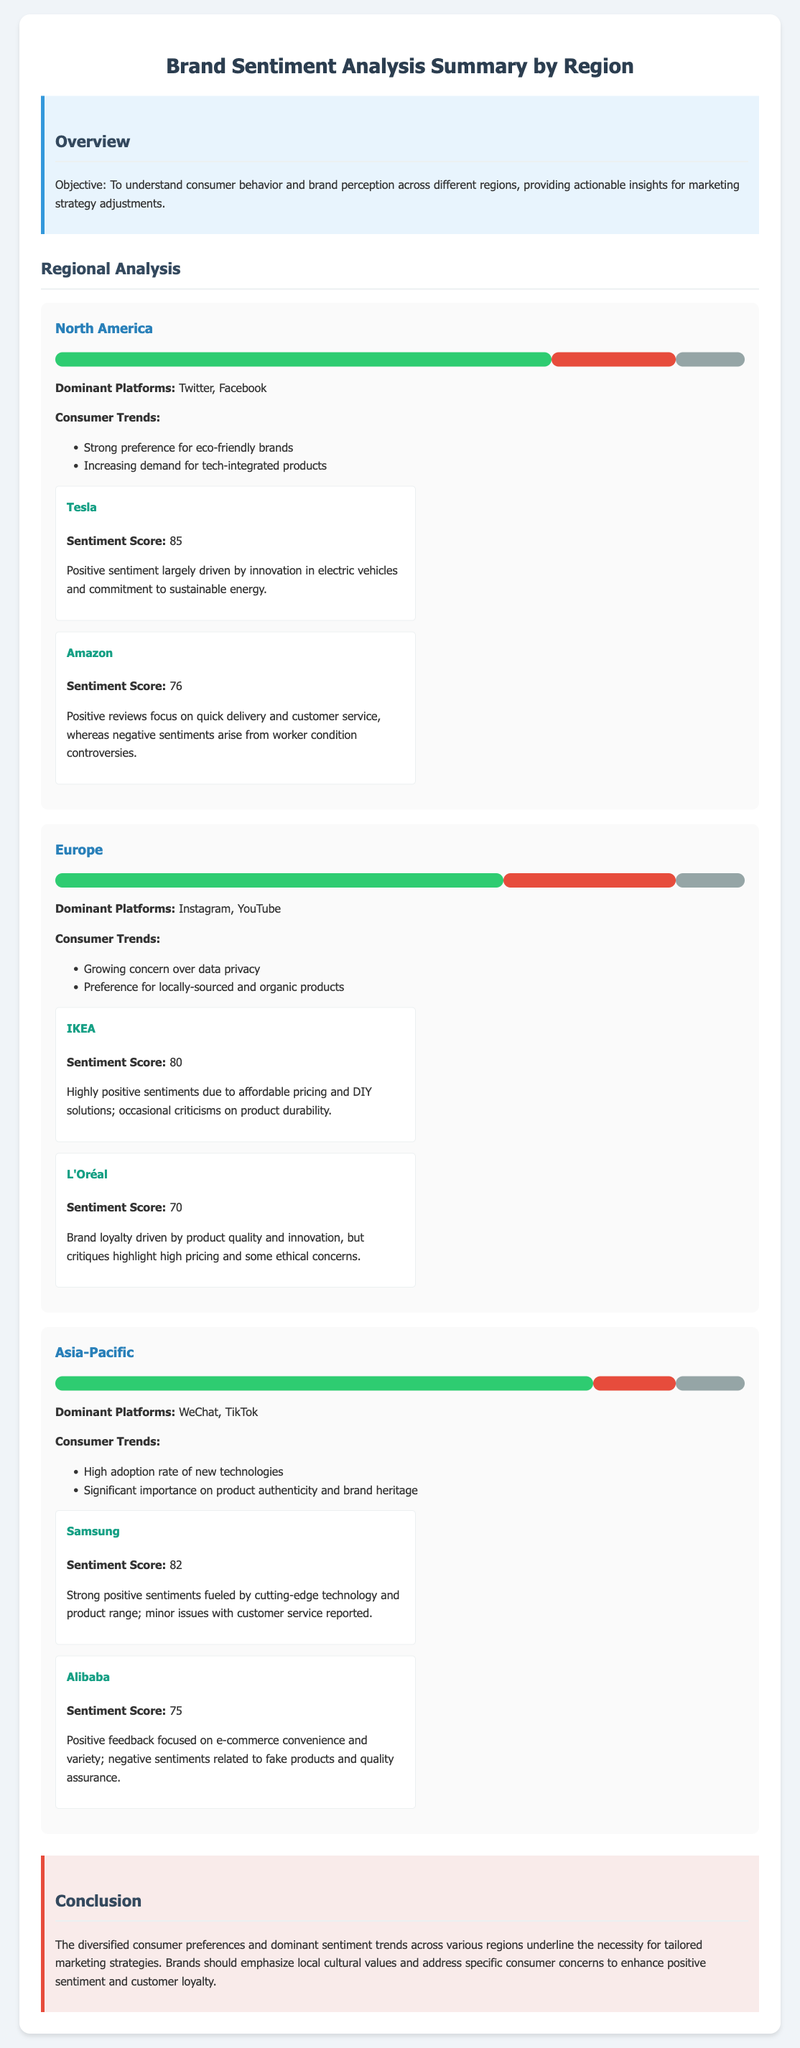What is the sentiment score for Tesla? The sentiment score for Tesla is mentioned specifically in the brand section under North America, which is 85.
Answer: 85 What are the dominant platforms in Europe? The dominant platforms for brand sentiment analysis in Europe are mentioned as Instagram and YouTube.
Answer: Instagram, YouTube What percentage of North America has positive sentiment? The positive sentiment percentage for North America is given in the sentiment chart, which is 72%.
Answer: 72% Which brand has a sentiment score of 70 in Europe? The brand L'Oréal is specifically noted to have a sentiment score of 70 in the Europe section.
Answer: L'Oréal What consumer trend is observed in the Asia-Pacific region? One consumer trend noted in the Asia-Pacific region is the high adoption rate of new technologies.
Answer: High adoption rate of new technologies Which region has the highest positive sentiment percentage? The highest positive sentiment percentage of 78% is shown in the Asia-Pacific region.
Answer: Asia-Pacific What is the conclusion regarding marketing strategies? The document concludes that brands should emphasize local cultural values and address specific consumer concerns to enhance sentiment and loyalty.
Answer: Tailored marketing strategies Which brand is highlighted for quick delivery in North America? Amazon is specifically highlighted for its quick delivery in the North America section.
Answer: Amazon 